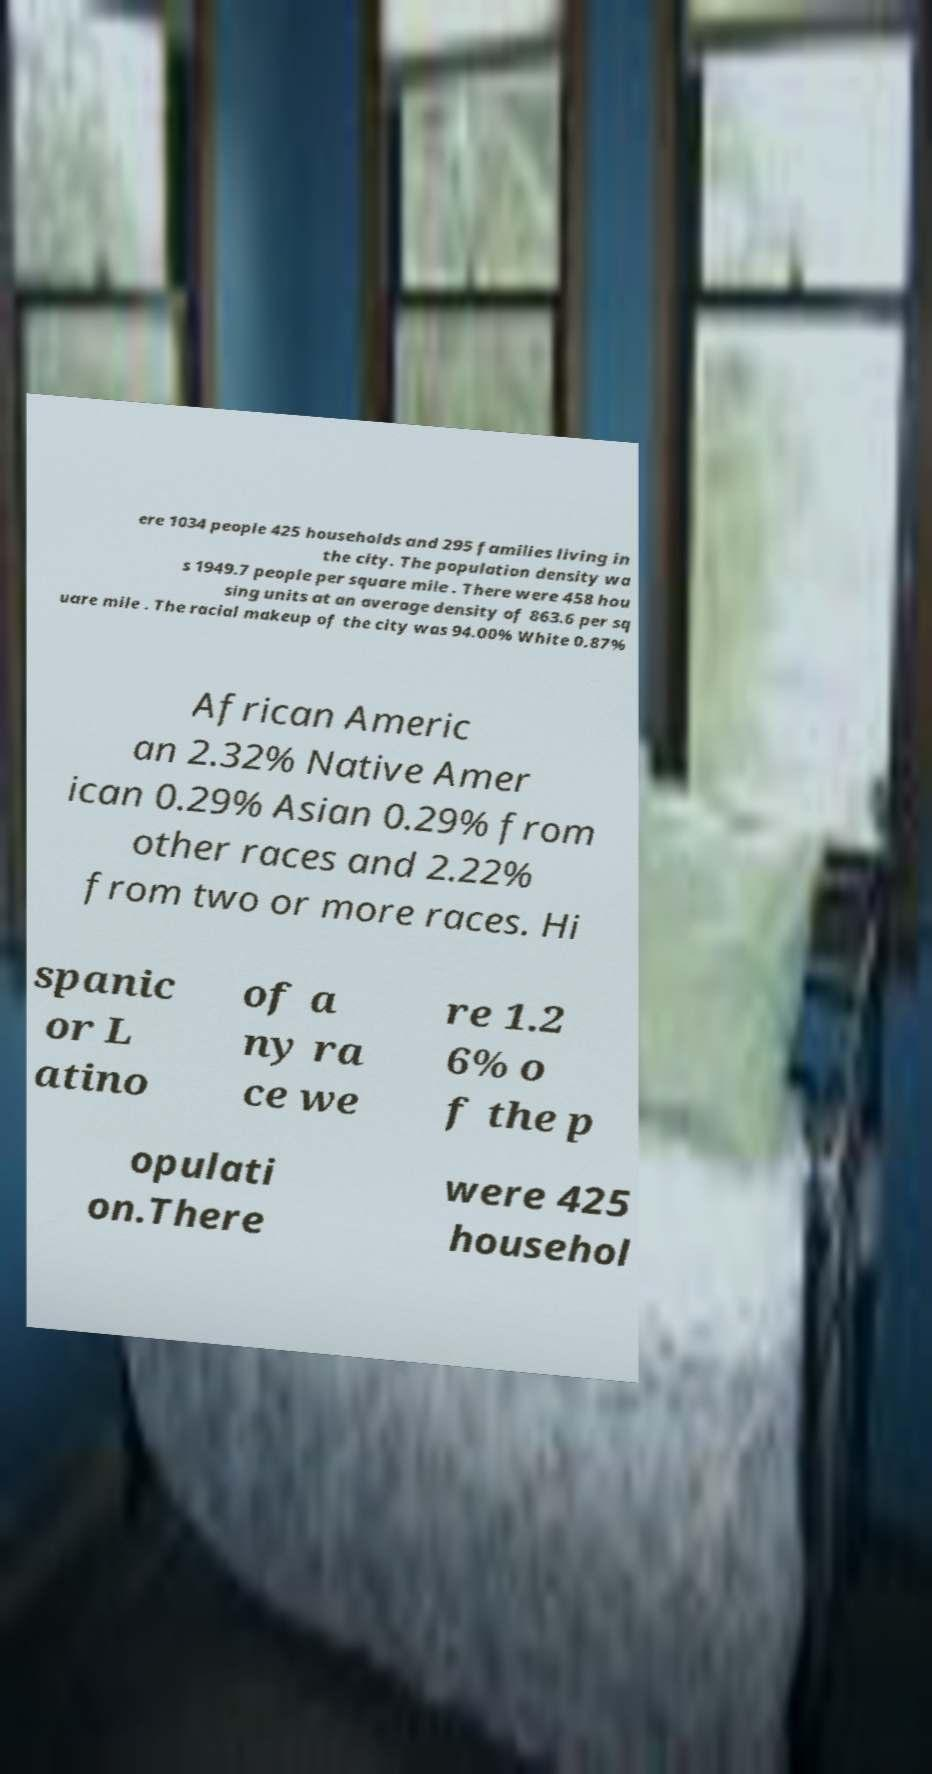I need the written content from this picture converted into text. Can you do that? ere 1034 people 425 households and 295 families living in the city. The population density wa s 1949.7 people per square mile . There were 458 hou sing units at an average density of 863.6 per sq uare mile . The racial makeup of the city was 94.00% White 0.87% African Americ an 2.32% Native Amer ican 0.29% Asian 0.29% from other races and 2.22% from two or more races. Hi spanic or L atino of a ny ra ce we re 1.2 6% o f the p opulati on.There were 425 househol 